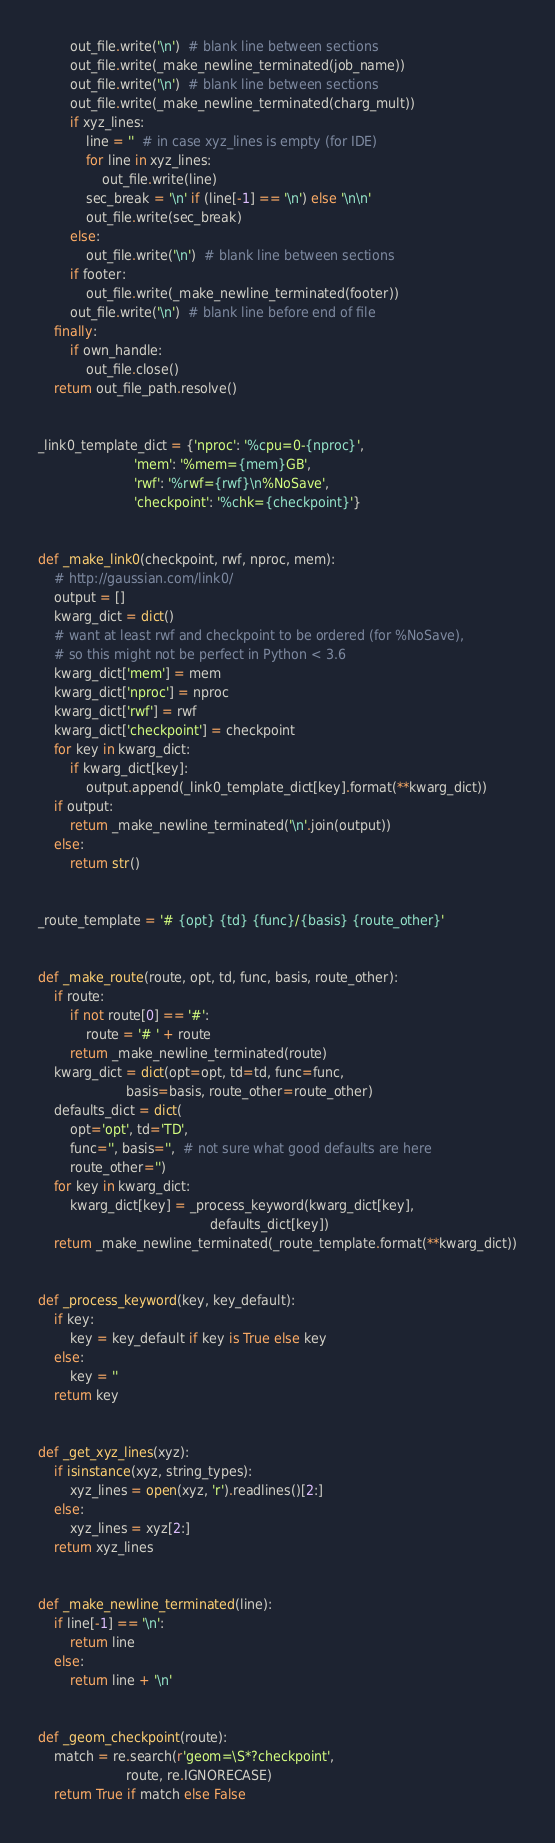<code> <loc_0><loc_0><loc_500><loc_500><_Python_>        out_file.write('\n')  # blank line between sections
        out_file.write(_make_newline_terminated(job_name))
        out_file.write('\n')  # blank line between sections
        out_file.write(_make_newline_terminated(charg_mult))
        if xyz_lines:
            line = ''  # in case xyz_lines is empty (for IDE)
            for line in xyz_lines:
                out_file.write(line)
            sec_break = '\n' if (line[-1] == '\n') else '\n\n'
            out_file.write(sec_break)
        else:
            out_file.write('\n')  # blank line between sections
        if footer:
            out_file.write(_make_newline_terminated(footer))
        out_file.write('\n')  # blank line before end of file
    finally:
        if own_handle:
            out_file.close()
    return out_file_path.resolve()


_link0_template_dict = {'nproc': '%cpu=0-{nproc}',
                        'mem': '%mem={mem}GB',
                        'rwf': '%rwf={rwf}\n%NoSave',
                        'checkpoint': '%chk={checkpoint}'}


def _make_link0(checkpoint, rwf, nproc, mem):
    # http://gaussian.com/link0/
    output = []
    kwarg_dict = dict()
    # want at least rwf and checkpoint to be ordered (for %NoSave),
    # so this might not be perfect in Python < 3.6
    kwarg_dict['mem'] = mem
    kwarg_dict['nproc'] = nproc
    kwarg_dict['rwf'] = rwf
    kwarg_dict['checkpoint'] = checkpoint
    for key in kwarg_dict:
        if kwarg_dict[key]:
            output.append(_link0_template_dict[key].format(**kwarg_dict))
    if output:
        return _make_newline_terminated('\n'.join(output))
    else:
        return str()


_route_template = '# {opt} {td} {func}/{basis} {route_other}'


def _make_route(route, opt, td, func, basis, route_other):
    if route:
        if not route[0] == '#':
            route = '# ' + route
        return _make_newline_terminated(route)
    kwarg_dict = dict(opt=opt, td=td, func=func,
                      basis=basis, route_other=route_other)
    defaults_dict = dict(
        opt='opt', td='TD',
        func='', basis='',  # not sure what good defaults are here
        route_other='')
    for key in kwarg_dict:
        kwarg_dict[key] = _process_keyword(kwarg_dict[key],
                                           defaults_dict[key])
    return _make_newline_terminated(_route_template.format(**kwarg_dict))


def _process_keyword(key, key_default):
    if key:
        key = key_default if key is True else key
    else:
        key = ''
    return key


def _get_xyz_lines(xyz):
    if isinstance(xyz, string_types):
        xyz_lines = open(xyz, 'r').readlines()[2:]
    else:
        xyz_lines = xyz[2:]
    return xyz_lines


def _make_newline_terminated(line):
    if line[-1] == '\n':
        return line
    else:
        return line + '\n'


def _geom_checkpoint(route):
    match = re.search(r'geom=\S*?checkpoint',
                      route, re.IGNORECASE)
    return True if match else False
</code> 